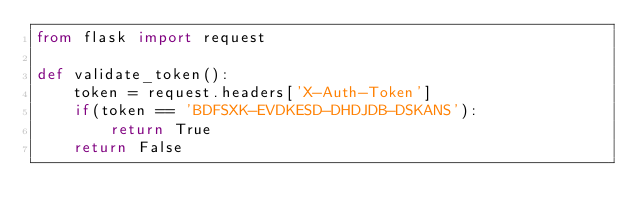<code> <loc_0><loc_0><loc_500><loc_500><_Python_>from flask import request

def validate_token():
    token = request.headers['X-Auth-Token']
    if(token == 'BDFSXK-EVDKESD-DHDJDB-DSKANS'):
        return True
    return False
</code> 